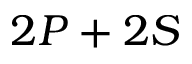Convert formula to latex. <formula><loc_0><loc_0><loc_500><loc_500>2 P + 2 S</formula> 